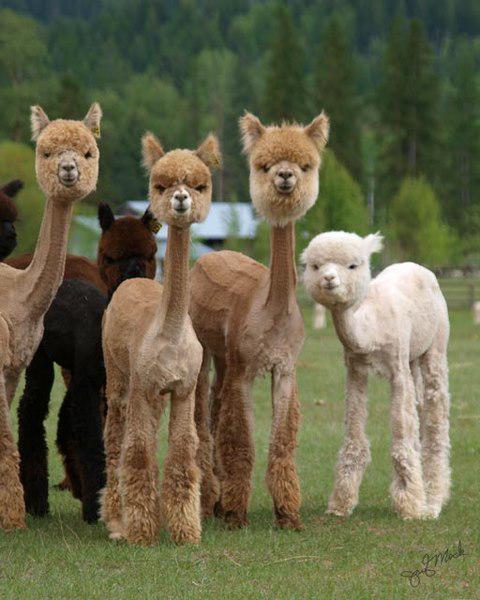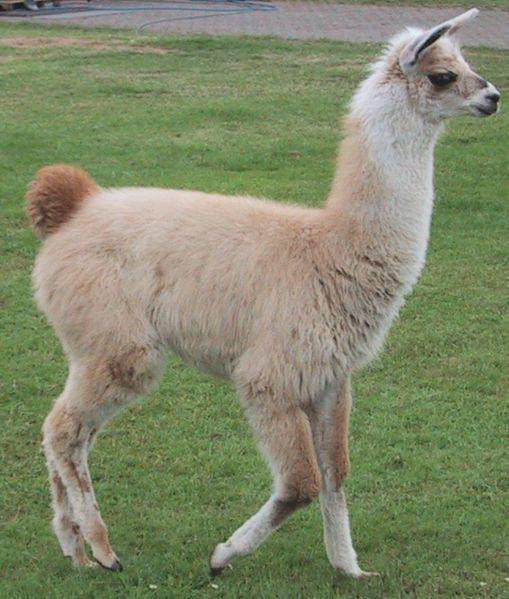The first image is the image on the left, the second image is the image on the right. Examine the images to the left and right. Is the description "The left and right image contains the same number of llamas." accurate? Answer yes or no. No. The first image is the image on the left, the second image is the image on the right. For the images shown, is this caption "An image features a white forward-facing llama showing its protruding lower teeth." true? Answer yes or no. No. 